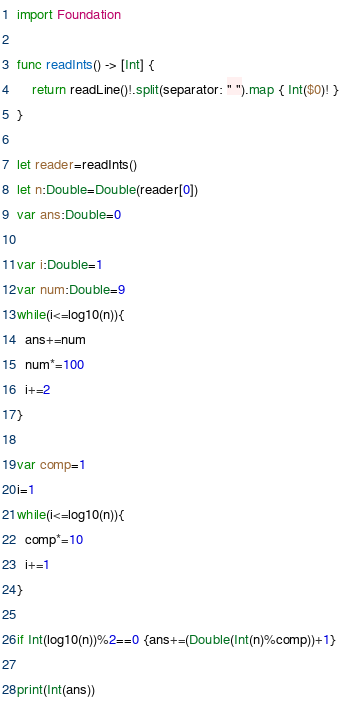Convert code to text. <code><loc_0><loc_0><loc_500><loc_500><_Swift_>import Foundation

func readInts() -> [Int] {
    return readLine()!.split(separator: " ").map { Int($0)! }
}

let reader=readInts()
let n:Double=Double(reader[0])
var ans:Double=0

var i:Double=1
var num:Double=9
while(i<=log10(n)){
  ans+=num
  num*=100
  i+=2
}

var comp=1
i=1
while(i<=log10(n)){
  comp*=10
  i+=1
}

if Int(log10(n))%2==0 {ans+=(Double(Int(n)%comp))+1}

print(Int(ans))</code> 